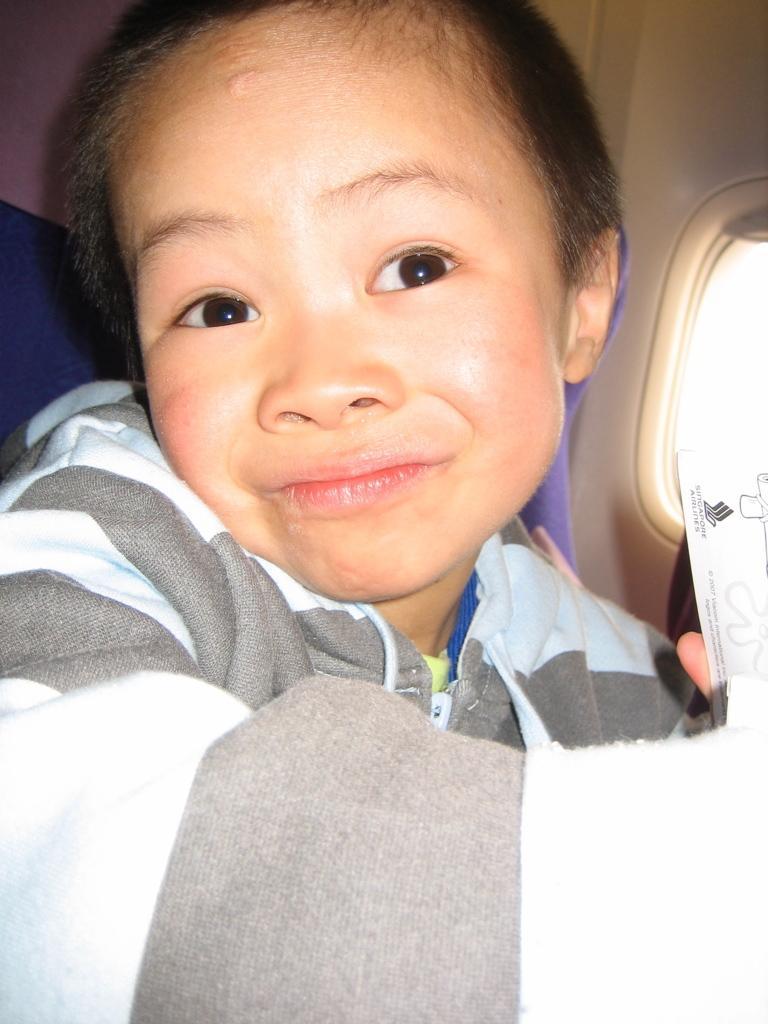Please provide a concise description of this image. In this picture I can see a kid in a vehicle, side we can see a window to the vehicle. 